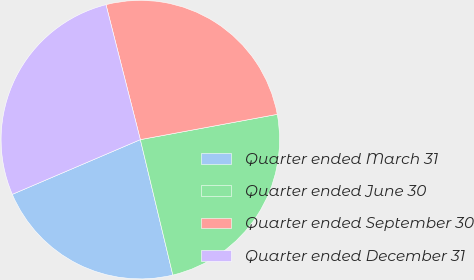Convert chart to OTSL. <chart><loc_0><loc_0><loc_500><loc_500><pie_chart><fcel>Quarter ended March 31<fcel>Quarter ended June 30<fcel>Quarter ended September 30<fcel>Quarter ended December 31<nl><fcel>22.32%<fcel>24.16%<fcel>26.06%<fcel>27.46%<nl></chart> 